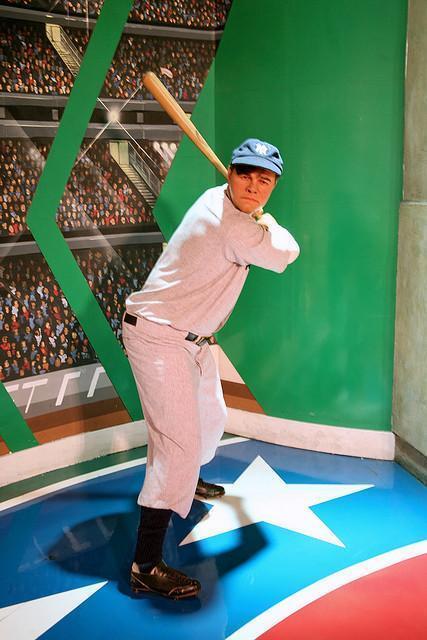How many white cows are there?
Give a very brief answer. 0. 